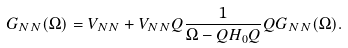<formula> <loc_0><loc_0><loc_500><loc_500>G _ { N N } ( \Omega ) = V _ { N N } + V _ { N N } Q \frac { 1 } { \Omega - Q H _ { 0 } Q } Q G _ { N N } ( \Omega ) .</formula> 